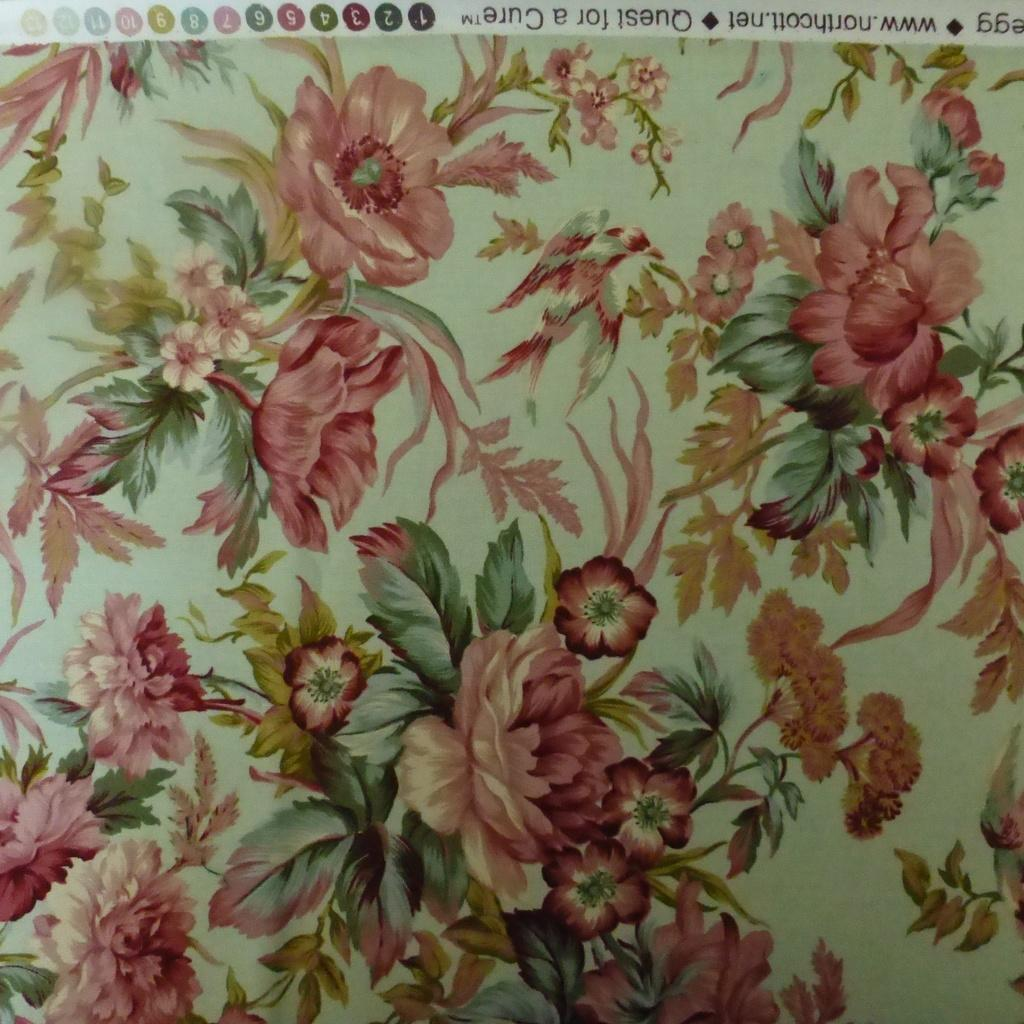What type of material is featured in the image? The image contains a cloth. What type of natural elements can be seen in the image? There are flowers and leaves present in the image. Is there any text visible in the image? Yes, there is text in the image. What type of punishment is being carried out in the image? There is no punishment or any indication of punishment in the image. Can you see any yaks in the image? There are no yaks present in the image. 